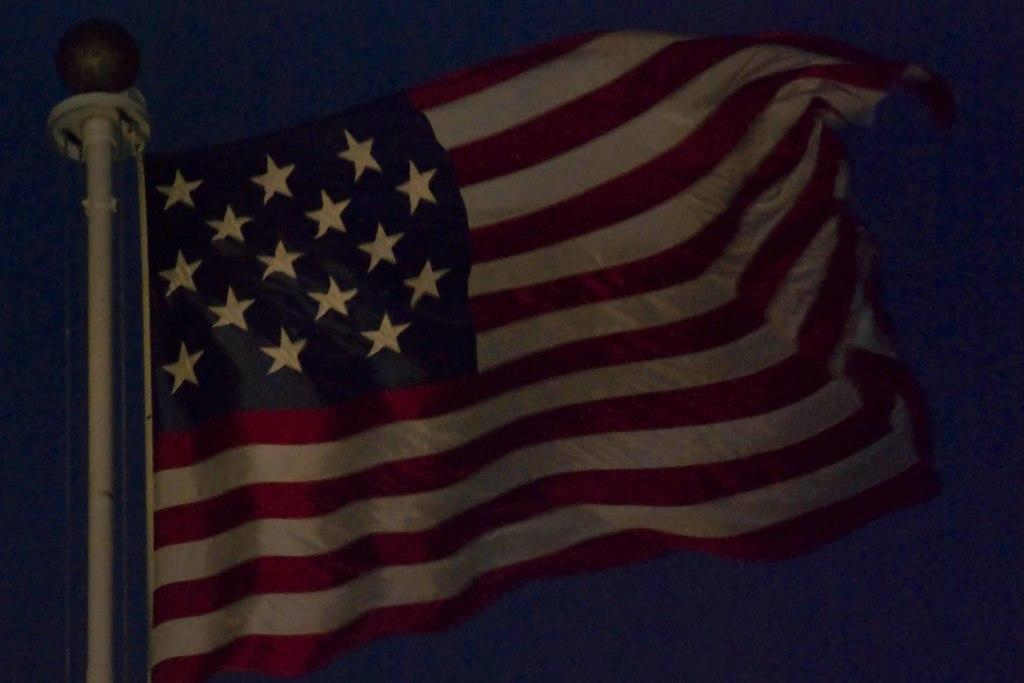What is the main object in the image? There is a flag in the image. What is the flag attached to? The flag is attached to a pole in the image. What can be observed about the background of the image? The background of the image is dark. What type of sound can be heard coming from the flag in the image? There is no sound coming from the flag in the image. Are there any sticks visible in the image? There are no sticks visible in the image. Can you see a tiger in the image? There is no tiger present in the image. 